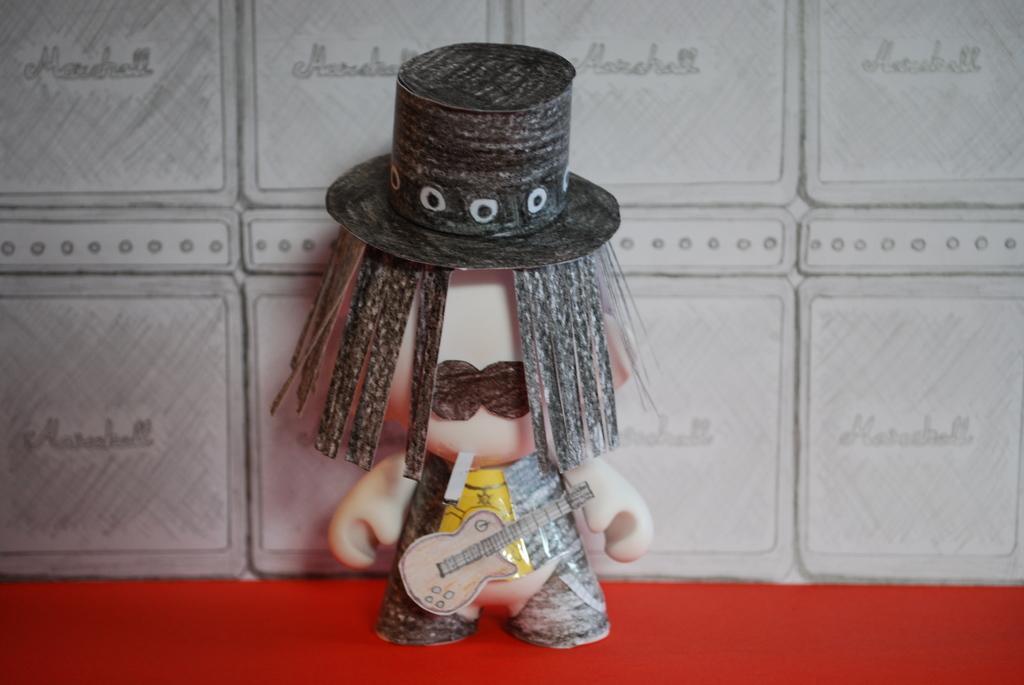How would you summarize this image in a sentence or two? In this image we can see a toy placed on the table. 